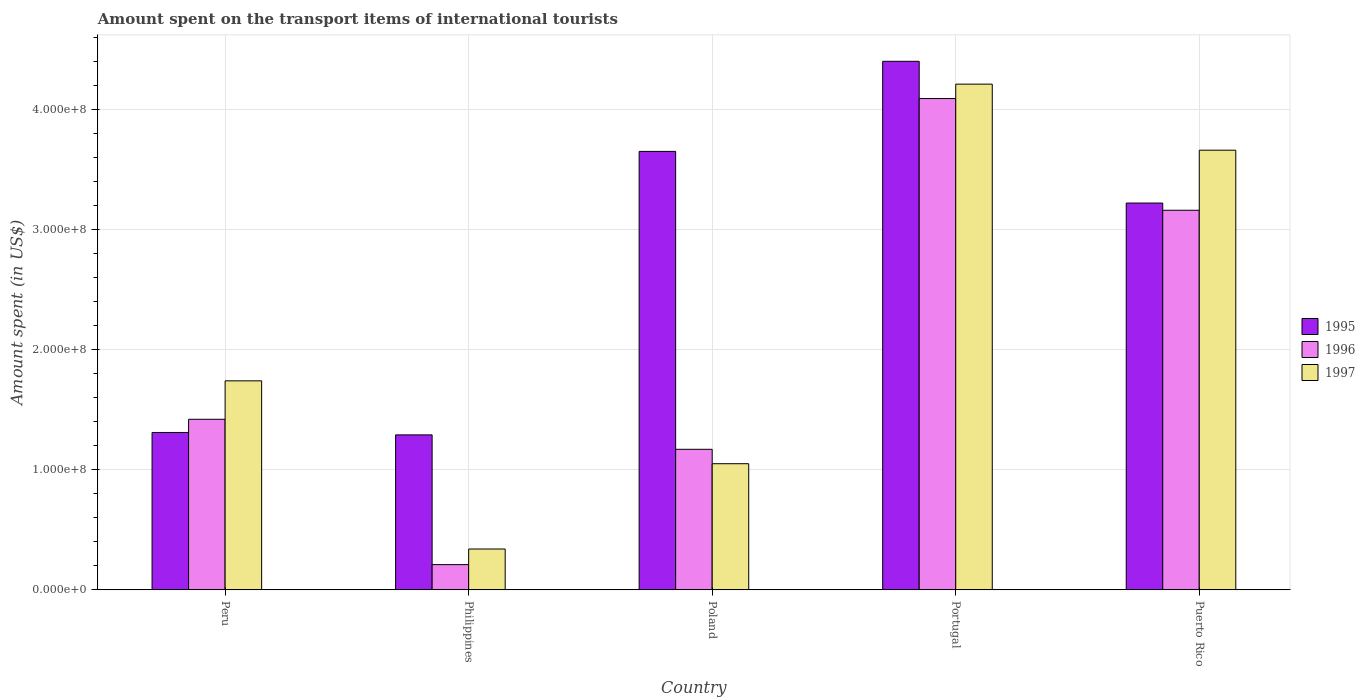How many different coloured bars are there?
Ensure brevity in your answer.  3. Are the number of bars per tick equal to the number of legend labels?
Make the answer very short. Yes. Are the number of bars on each tick of the X-axis equal?
Make the answer very short. Yes. What is the label of the 2nd group of bars from the left?
Provide a succinct answer. Philippines. In how many cases, is the number of bars for a given country not equal to the number of legend labels?
Provide a short and direct response. 0. What is the amount spent on the transport items of international tourists in 1997 in Portugal?
Provide a short and direct response. 4.21e+08. Across all countries, what is the maximum amount spent on the transport items of international tourists in 1996?
Ensure brevity in your answer.  4.09e+08. Across all countries, what is the minimum amount spent on the transport items of international tourists in 1997?
Ensure brevity in your answer.  3.40e+07. In which country was the amount spent on the transport items of international tourists in 1995 maximum?
Your answer should be very brief. Portugal. What is the total amount spent on the transport items of international tourists in 1995 in the graph?
Your answer should be compact. 1.39e+09. What is the difference between the amount spent on the transport items of international tourists in 1997 in Philippines and that in Puerto Rico?
Ensure brevity in your answer.  -3.32e+08. What is the difference between the amount spent on the transport items of international tourists in 1997 in Puerto Rico and the amount spent on the transport items of international tourists in 1995 in Portugal?
Keep it short and to the point. -7.40e+07. What is the average amount spent on the transport items of international tourists in 1996 per country?
Give a very brief answer. 2.01e+08. What is the difference between the amount spent on the transport items of international tourists of/in 1997 and amount spent on the transport items of international tourists of/in 1996 in Philippines?
Your answer should be very brief. 1.30e+07. In how many countries, is the amount spent on the transport items of international tourists in 1996 greater than 80000000 US$?
Make the answer very short. 4. What is the ratio of the amount spent on the transport items of international tourists in 1995 in Peru to that in Portugal?
Make the answer very short. 0.3. What is the difference between the highest and the second highest amount spent on the transport items of international tourists in 1995?
Keep it short and to the point. 7.50e+07. What is the difference between the highest and the lowest amount spent on the transport items of international tourists in 1995?
Offer a very short reply. 3.11e+08. In how many countries, is the amount spent on the transport items of international tourists in 1995 greater than the average amount spent on the transport items of international tourists in 1995 taken over all countries?
Provide a short and direct response. 3. What does the 3rd bar from the left in Philippines represents?
Your answer should be compact. 1997. What does the 3rd bar from the right in Puerto Rico represents?
Provide a succinct answer. 1995. How many bars are there?
Provide a short and direct response. 15. What is the difference between two consecutive major ticks on the Y-axis?
Provide a short and direct response. 1.00e+08. Does the graph contain any zero values?
Your answer should be very brief. No. Does the graph contain grids?
Give a very brief answer. Yes. Where does the legend appear in the graph?
Your answer should be compact. Center right. How many legend labels are there?
Your answer should be very brief. 3. What is the title of the graph?
Your response must be concise. Amount spent on the transport items of international tourists. What is the label or title of the Y-axis?
Keep it short and to the point. Amount spent (in US$). What is the Amount spent (in US$) in 1995 in Peru?
Provide a short and direct response. 1.31e+08. What is the Amount spent (in US$) in 1996 in Peru?
Your answer should be very brief. 1.42e+08. What is the Amount spent (in US$) in 1997 in Peru?
Provide a short and direct response. 1.74e+08. What is the Amount spent (in US$) of 1995 in Philippines?
Offer a terse response. 1.29e+08. What is the Amount spent (in US$) of 1996 in Philippines?
Your response must be concise. 2.10e+07. What is the Amount spent (in US$) in 1997 in Philippines?
Give a very brief answer. 3.40e+07. What is the Amount spent (in US$) of 1995 in Poland?
Keep it short and to the point. 3.65e+08. What is the Amount spent (in US$) in 1996 in Poland?
Your answer should be very brief. 1.17e+08. What is the Amount spent (in US$) in 1997 in Poland?
Ensure brevity in your answer.  1.05e+08. What is the Amount spent (in US$) of 1995 in Portugal?
Make the answer very short. 4.40e+08. What is the Amount spent (in US$) of 1996 in Portugal?
Give a very brief answer. 4.09e+08. What is the Amount spent (in US$) of 1997 in Portugal?
Keep it short and to the point. 4.21e+08. What is the Amount spent (in US$) of 1995 in Puerto Rico?
Your response must be concise. 3.22e+08. What is the Amount spent (in US$) of 1996 in Puerto Rico?
Make the answer very short. 3.16e+08. What is the Amount spent (in US$) of 1997 in Puerto Rico?
Give a very brief answer. 3.66e+08. Across all countries, what is the maximum Amount spent (in US$) in 1995?
Keep it short and to the point. 4.40e+08. Across all countries, what is the maximum Amount spent (in US$) of 1996?
Offer a terse response. 4.09e+08. Across all countries, what is the maximum Amount spent (in US$) of 1997?
Your answer should be compact. 4.21e+08. Across all countries, what is the minimum Amount spent (in US$) in 1995?
Provide a succinct answer. 1.29e+08. Across all countries, what is the minimum Amount spent (in US$) of 1996?
Give a very brief answer. 2.10e+07. Across all countries, what is the minimum Amount spent (in US$) in 1997?
Offer a terse response. 3.40e+07. What is the total Amount spent (in US$) of 1995 in the graph?
Your answer should be compact. 1.39e+09. What is the total Amount spent (in US$) of 1996 in the graph?
Provide a succinct answer. 1.00e+09. What is the total Amount spent (in US$) in 1997 in the graph?
Your answer should be very brief. 1.10e+09. What is the difference between the Amount spent (in US$) of 1996 in Peru and that in Philippines?
Keep it short and to the point. 1.21e+08. What is the difference between the Amount spent (in US$) in 1997 in Peru and that in Philippines?
Provide a succinct answer. 1.40e+08. What is the difference between the Amount spent (in US$) of 1995 in Peru and that in Poland?
Your answer should be compact. -2.34e+08. What is the difference between the Amount spent (in US$) in 1996 in Peru and that in Poland?
Your response must be concise. 2.50e+07. What is the difference between the Amount spent (in US$) in 1997 in Peru and that in Poland?
Make the answer very short. 6.90e+07. What is the difference between the Amount spent (in US$) in 1995 in Peru and that in Portugal?
Make the answer very short. -3.09e+08. What is the difference between the Amount spent (in US$) of 1996 in Peru and that in Portugal?
Ensure brevity in your answer.  -2.67e+08. What is the difference between the Amount spent (in US$) of 1997 in Peru and that in Portugal?
Provide a succinct answer. -2.47e+08. What is the difference between the Amount spent (in US$) in 1995 in Peru and that in Puerto Rico?
Provide a succinct answer. -1.91e+08. What is the difference between the Amount spent (in US$) of 1996 in Peru and that in Puerto Rico?
Give a very brief answer. -1.74e+08. What is the difference between the Amount spent (in US$) in 1997 in Peru and that in Puerto Rico?
Offer a very short reply. -1.92e+08. What is the difference between the Amount spent (in US$) in 1995 in Philippines and that in Poland?
Make the answer very short. -2.36e+08. What is the difference between the Amount spent (in US$) of 1996 in Philippines and that in Poland?
Your answer should be compact. -9.60e+07. What is the difference between the Amount spent (in US$) of 1997 in Philippines and that in Poland?
Provide a short and direct response. -7.10e+07. What is the difference between the Amount spent (in US$) in 1995 in Philippines and that in Portugal?
Make the answer very short. -3.11e+08. What is the difference between the Amount spent (in US$) in 1996 in Philippines and that in Portugal?
Make the answer very short. -3.88e+08. What is the difference between the Amount spent (in US$) in 1997 in Philippines and that in Portugal?
Give a very brief answer. -3.87e+08. What is the difference between the Amount spent (in US$) of 1995 in Philippines and that in Puerto Rico?
Ensure brevity in your answer.  -1.93e+08. What is the difference between the Amount spent (in US$) in 1996 in Philippines and that in Puerto Rico?
Offer a terse response. -2.95e+08. What is the difference between the Amount spent (in US$) in 1997 in Philippines and that in Puerto Rico?
Ensure brevity in your answer.  -3.32e+08. What is the difference between the Amount spent (in US$) in 1995 in Poland and that in Portugal?
Offer a terse response. -7.50e+07. What is the difference between the Amount spent (in US$) of 1996 in Poland and that in Portugal?
Offer a terse response. -2.92e+08. What is the difference between the Amount spent (in US$) in 1997 in Poland and that in Portugal?
Ensure brevity in your answer.  -3.16e+08. What is the difference between the Amount spent (in US$) of 1995 in Poland and that in Puerto Rico?
Keep it short and to the point. 4.30e+07. What is the difference between the Amount spent (in US$) of 1996 in Poland and that in Puerto Rico?
Offer a terse response. -1.99e+08. What is the difference between the Amount spent (in US$) in 1997 in Poland and that in Puerto Rico?
Ensure brevity in your answer.  -2.61e+08. What is the difference between the Amount spent (in US$) in 1995 in Portugal and that in Puerto Rico?
Ensure brevity in your answer.  1.18e+08. What is the difference between the Amount spent (in US$) of 1996 in Portugal and that in Puerto Rico?
Ensure brevity in your answer.  9.30e+07. What is the difference between the Amount spent (in US$) of 1997 in Portugal and that in Puerto Rico?
Your answer should be very brief. 5.50e+07. What is the difference between the Amount spent (in US$) of 1995 in Peru and the Amount spent (in US$) of 1996 in Philippines?
Provide a succinct answer. 1.10e+08. What is the difference between the Amount spent (in US$) in 1995 in Peru and the Amount spent (in US$) in 1997 in Philippines?
Offer a very short reply. 9.70e+07. What is the difference between the Amount spent (in US$) of 1996 in Peru and the Amount spent (in US$) of 1997 in Philippines?
Your response must be concise. 1.08e+08. What is the difference between the Amount spent (in US$) of 1995 in Peru and the Amount spent (in US$) of 1996 in Poland?
Provide a succinct answer. 1.40e+07. What is the difference between the Amount spent (in US$) in 1995 in Peru and the Amount spent (in US$) in 1997 in Poland?
Your response must be concise. 2.60e+07. What is the difference between the Amount spent (in US$) in 1996 in Peru and the Amount spent (in US$) in 1997 in Poland?
Your answer should be compact. 3.70e+07. What is the difference between the Amount spent (in US$) in 1995 in Peru and the Amount spent (in US$) in 1996 in Portugal?
Provide a short and direct response. -2.78e+08. What is the difference between the Amount spent (in US$) of 1995 in Peru and the Amount spent (in US$) of 1997 in Portugal?
Provide a succinct answer. -2.90e+08. What is the difference between the Amount spent (in US$) of 1996 in Peru and the Amount spent (in US$) of 1997 in Portugal?
Provide a short and direct response. -2.79e+08. What is the difference between the Amount spent (in US$) in 1995 in Peru and the Amount spent (in US$) in 1996 in Puerto Rico?
Ensure brevity in your answer.  -1.85e+08. What is the difference between the Amount spent (in US$) in 1995 in Peru and the Amount spent (in US$) in 1997 in Puerto Rico?
Provide a succinct answer. -2.35e+08. What is the difference between the Amount spent (in US$) of 1996 in Peru and the Amount spent (in US$) of 1997 in Puerto Rico?
Ensure brevity in your answer.  -2.24e+08. What is the difference between the Amount spent (in US$) in 1995 in Philippines and the Amount spent (in US$) in 1997 in Poland?
Provide a succinct answer. 2.40e+07. What is the difference between the Amount spent (in US$) of 1996 in Philippines and the Amount spent (in US$) of 1997 in Poland?
Offer a very short reply. -8.40e+07. What is the difference between the Amount spent (in US$) of 1995 in Philippines and the Amount spent (in US$) of 1996 in Portugal?
Give a very brief answer. -2.80e+08. What is the difference between the Amount spent (in US$) in 1995 in Philippines and the Amount spent (in US$) in 1997 in Portugal?
Make the answer very short. -2.92e+08. What is the difference between the Amount spent (in US$) in 1996 in Philippines and the Amount spent (in US$) in 1997 in Portugal?
Provide a short and direct response. -4.00e+08. What is the difference between the Amount spent (in US$) of 1995 in Philippines and the Amount spent (in US$) of 1996 in Puerto Rico?
Your answer should be compact. -1.87e+08. What is the difference between the Amount spent (in US$) of 1995 in Philippines and the Amount spent (in US$) of 1997 in Puerto Rico?
Your response must be concise. -2.37e+08. What is the difference between the Amount spent (in US$) in 1996 in Philippines and the Amount spent (in US$) in 1997 in Puerto Rico?
Make the answer very short. -3.45e+08. What is the difference between the Amount spent (in US$) of 1995 in Poland and the Amount spent (in US$) of 1996 in Portugal?
Give a very brief answer. -4.40e+07. What is the difference between the Amount spent (in US$) in 1995 in Poland and the Amount spent (in US$) in 1997 in Portugal?
Offer a very short reply. -5.60e+07. What is the difference between the Amount spent (in US$) in 1996 in Poland and the Amount spent (in US$) in 1997 in Portugal?
Your answer should be compact. -3.04e+08. What is the difference between the Amount spent (in US$) in 1995 in Poland and the Amount spent (in US$) in 1996 in Puerto Rico?
Offer a terse response. 4.90e+07. What is the difference between the Amount spent (in US$) of 1995 in Poland and the Amount spent (in US$) of 1997 in Puerto Rico?
Provide a succinct answer. -1.00e+06. What is the difference between the Amount spent (in US$) in 1996 in Poland and the Amount spent (in US$) in 1997 in Puerto Rico?
Give a very brief answer. -2.49e+08. What is the difference between the Amount spent (in US$) of 1995 in Portugal and the Amount spent (in US$) of 1996 in Puerto Rico?
Offer a very short reply. 1.24e+08. What is the difference between the Amount spent (in US$) of 1995 in Portugal and the Amount spent (in US$) of 1997 in Puerto Rico?
Keep it short and to the point. 7.40e+07. What is the difference between the Amount spent (in US$) of 1996 in Portugal and the Amount spent (in US$) of 1997 in Puerto Rico?
Give a very brief answer. 4.30e+07. What is the average Amount spent (in US$) in 1995 per country?
Give a very brief answer. 2.77e+08. What is the average Amount spent (in US$) in 1996 per country?
Ensure brevity in your answer.  2.01e+08. What is the average Amount spent (in US$) of 1997 per country?
Keep it short and to the point. 2.20e+08. What is the difference between the Amount spent (in US$) in 1995 and Amount spent (in US$) in 1996 in Peru?
Your response must be concise. -1.10e+07. What is the difference between the Amount spent (in US$) of 1995 and Amount spent (in US$) of 1997 in Peru?
Your answer should be very brief. -4.30e+07. What is the difference between the Amount spent (in US$) of 1996 and Amount spent (in US$) of 1997 in Peru?
Keep it short and to the point. -3.20e+07. What is the difference between the Amount spent (in US$) of 1995 and Amount spent (in US$) of 1996 in Philippines?
Provide a short and direct response. 1.08e+08. What is the difference between the Amount spent (in US$) in 1995 and Amount spent (in US$) in 1997 in Philippines?
Ensure brevity in your answer.  9.50e+07. What is the difference between the Amount spent (in US$) of 1996 and Amount spent (in US$) of 1997 in Philippines?
Ensure brevity in your answer.  -1.30e+07. What is the difference between the Amount spent (in US$) in 1995 and Amount spent (in US$) in 1996 in Poland?
Provide a succinct answer. 2.48e+08. What is the difference between the Amount spent (in US$) of 1995 and Amount spent (in US$) of 1997 in Poland?
Offer a terse response. 2.60e+08. What is the difference between the Amount spent (in US$) in 1995 and Amount spent (in US$) in 1996 in Portugal?
Provide a succinct answer. 3.10e+07. What is the difference between the Amount spent (in US$) of 1995 and Amount spent (in US$) of 1997 in Portugal?
Make the answer very short. 1.90e+07. What is the difference between the Amount spent (in US$) of 1996 and Amount spent (in US$) of 1997 in Portugal?
Offer a very short reply. -1.20e+07. What is the difference between the Amount spent (in US$) of 1995 and Amount spent (in US$) of 1996 in Puerto Rico?
Ensure brevity in your answer.  6.00e+06. What is the difference between the Amount spent (in US$) in 1995 and Amount spent (in US$) in 1997 in Puerto Rico?
Your response must be concise. -4.40e+07. What is the difference between the Amount spent (in US$) of 1996 and Amount spent (in US$) of 1997 in Puerto Rico?
Keep it short and to the point. -5.00e+07. What is the ratio of the Amount spent (in US$) in 1995 in Peru to that in Philippines?
Offer a very short reply. 1.02. What is the ratio of the Amount spent (in US$) in 1996 in Peru to that in Philippines?
Give a very brief answer. 6.76. What is the ratio of the Amount spent (in US$) of 1997 in Peru to that in Philippines?
Offer a terse response. 5.12. What is the ratio of the Amount spent (in US$) in 1995 in Peru to that in Poland?
Ensure brevity in your answer.  0.36. What is the ratio of the Amount spent (in US$) in 1996 in Peru to that in Poland?
Keep it short and to the point. 1.21. What is the ratio of the Amount spent (in US$) of 1997 in Peru to that in Poland?
Your answer should be compact. 1.66. What is the ratio of the Amount spent (in US$) of 1995 in Peru to that in Portugal?
Give a very brief answer. 0.3. What is the ratio of the Amount spent (in US$) of 1996 in Peru to that in Portugal?
Your answer should be very brief. 0.35. What is the ratio of the Amount spent (in US$) of 1997 in Peru to that in Portugal?
Give a very brief answer. 0.41. What is the ratio of the Amount spent (in US$) in 1995 in Peru to that in Puerto Rico?
Your answer should be very brief. 0.41. What is the ratio of the Amount spent (in US$) in 1996 in Peru to that in Puerto Rico?
Offer a terse response. 0.45. What is the ratio of the Amount spent (in US$) of 1997 in Peru to that in Puerto Rico?
Make the answer very short. 0.48. What is the ratio of the Amount spent (in US$) of 1995 in Philippines to that in Poland?
Give a very brief answer. 0.35. What is the ratio of the Amount spent (in US$) in 1996 in Philippines to that in Poland?
Offer a terse response. 0.18. What is the ratio of the Amount spent (in US$) in 1997 in Philippines to that in Poland?
Provide a short and direct response. 0.32. What is the ratio of the Amount spent (in US$) of 1995 in Philippines to that in Portugal?
Provide a short and direct response. 0.29. What is the ratio of the Amount spent (in US$) of 1996 in Philippines to that in Portugal?
Offer a very short reply. 0.05. What is the ratio of the Amount spent (in US$) in 1997 in Philippines to that in Portugal?
Make the answer very short. 0.08. What is the ratio of the Amount spent (in US$) of 1995 in Philippines to that in Puerto Rico?
Your answer should be very brief. 0.4. What is the ratio of the Amount spent (in US$) in 1996 in Philippines to that in Puerto Rico?
Make the answer very short. 0.07. What is the ratio of the Amount spent (in US$) in 1997 in Philippines to that in Puerto Rico?
Keep it short and to the point. 0.09. What is the ratio of the Amount spent (in US$) in 1995 in Poland to that in Portugal?
Your response must be concise. 0.83. What is the ratio of the Amount spent (in US$) in 1996 in Poland to that in Portugal?
Make the answer very short. 0.29. What is the ratio of the Amount spent (in US$) in 1997 in Poland to that in Portugal?
Provide a short and direct response. 0.25. What is the ratio of the Amount spent (in US$) of 1995 in Poland to that in Puerto Rico?
Give a very brief answer. 1.13. What is the ratio of the Amount spent (in US$) of 1996 in Poland to that in Puerto Rico?
Provide a short and direct response. 0.37. What is the ratio of the Amount spent (in US$) of 1997 in Poland to that in Puerto Rico?
Ensure brevity in your answer.  0.29. What is the ratio of the Amount spent (in US$) of 1995 in Portugal to that in Puerto Rico?
Offer a terse response. 1.37. What is the ratio of the Amount spent (in US$) of 1996 in Portugal to that in Puerto Rico?
Your answer should be compact. 1.29. What is the ratio of the Amount spent (in US$) in 1997 in Portugal to that in Puerto Rico?
Your response must be concise. 1.15. What is the difference between the highest and the second highest Amount spent (in US$) in 1995?
Give a very brief answer. 7.50e+07. What is the difference between the highest and the second highest Amount spent (in US$) in 1996?
Your answer should be compact. 9.30e+07. What is the difference between the highest and the second highest Amount spent (in US$) of 1997?
Ensure brevity in your answer.  5.50e+07. What is the difference between the highest and the lowest Amount spent (in US$) in 1995?
Give a very brief answer. 3.11e+08. What is the difference between the highest and the lowest Amount spent (in US$) in 1996?
Keep it short and to the point. 3.88e+08. What is the difference between the highest and the lowest Amount spent (in US$) in 1997?
Provide a succinct answer. 3.87e+08. 